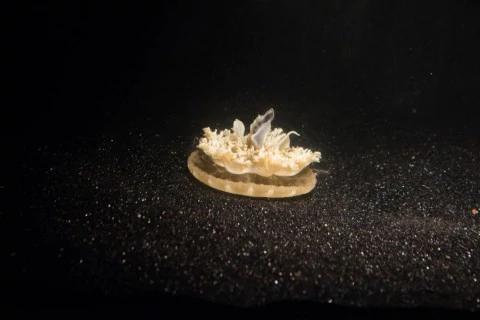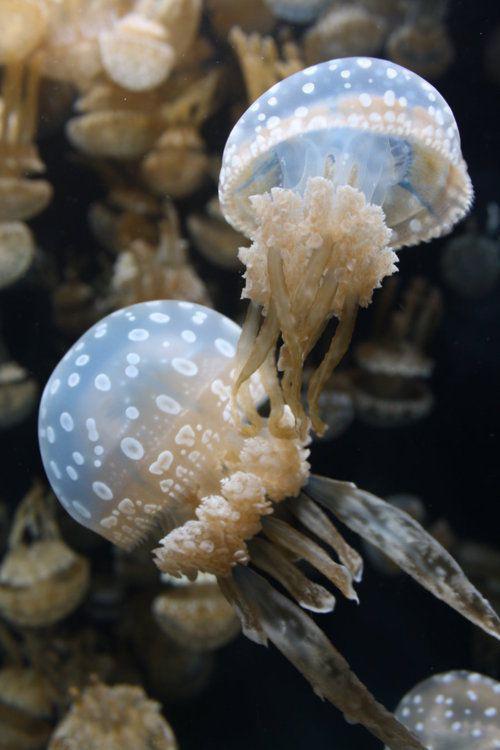The first image is the image on the left, the second image is the image on the right. Evaluate the accuracy of this statement regarding the images: "The jellyfish in the left and right images share the same shape 'caps' and are positioned with their tentacles facing the same direction.". Is it true? Answer yes or no. No. The first image is the image on the left, the second image is the image on the right. Given the left and right images, does the statement "Exactly one creature is sitting on the bottom." hold true? Answer yes or no. Yes. 